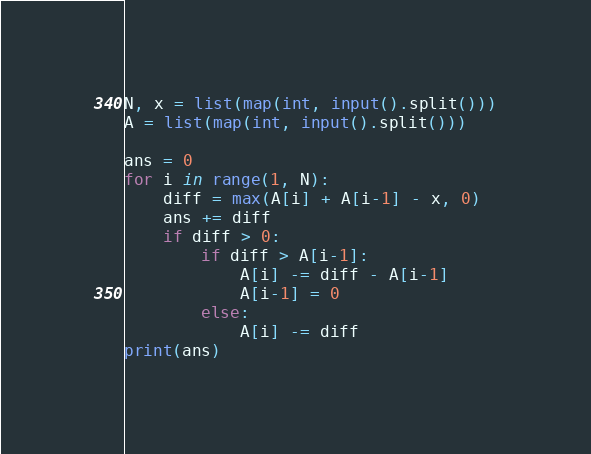<code> <loc_0><loc_0><loc_500><loc_500><_Python_>N, x = list(map(int, input().split()))
A = list(map(int, input().split()))

ans = 0
for i in range(1, N):
    diff = max(A[i] + A[i-1] - x, 0)
    ans += diff
    if diff > 0:
        if diff > A[i-1]:
            A[i] -= diff - A[i-1]
            A[i-1] = 0
        else:
            A[i] -= diff
print(ans)
</code> 